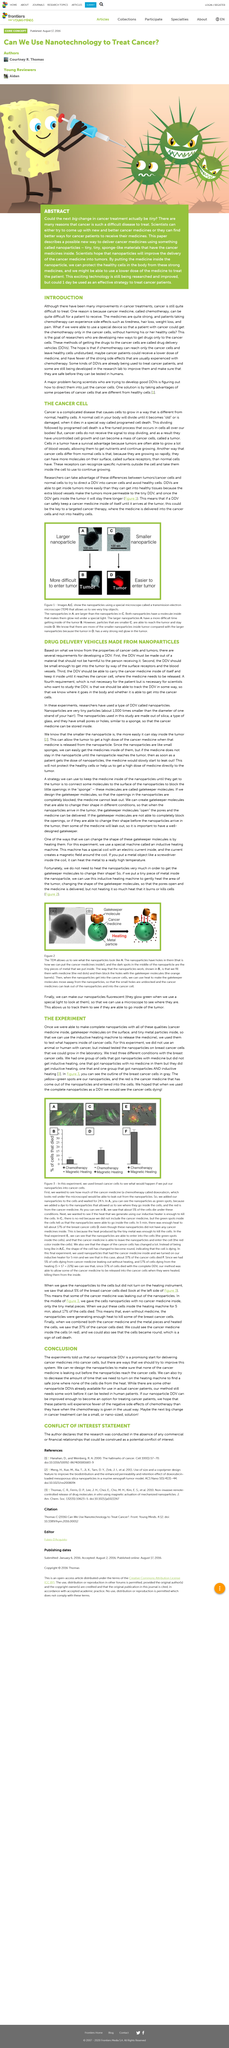Give some essential details in this illustration. Programmed cell death, also known as apoptosis, occurs when normal cells undergo a controlled and timed process of death in response to various stimuli. The TEM (transmission electron microscope) enables us to observe the appearance of nanoparticles. It is possible to modify a gatekeeper molecule by subjecting it to heat. The use of fluorescent nanoparticles is necessary in order to visualize their location using a microscope. This enables us to track their movement and determine their effectiveness in targeting tumors. Cancer is a disease characterized by the abnormal growth of cells, leading to the formation of tumors that can invade and damage surrounding tissues and spread to other parts of the body. 